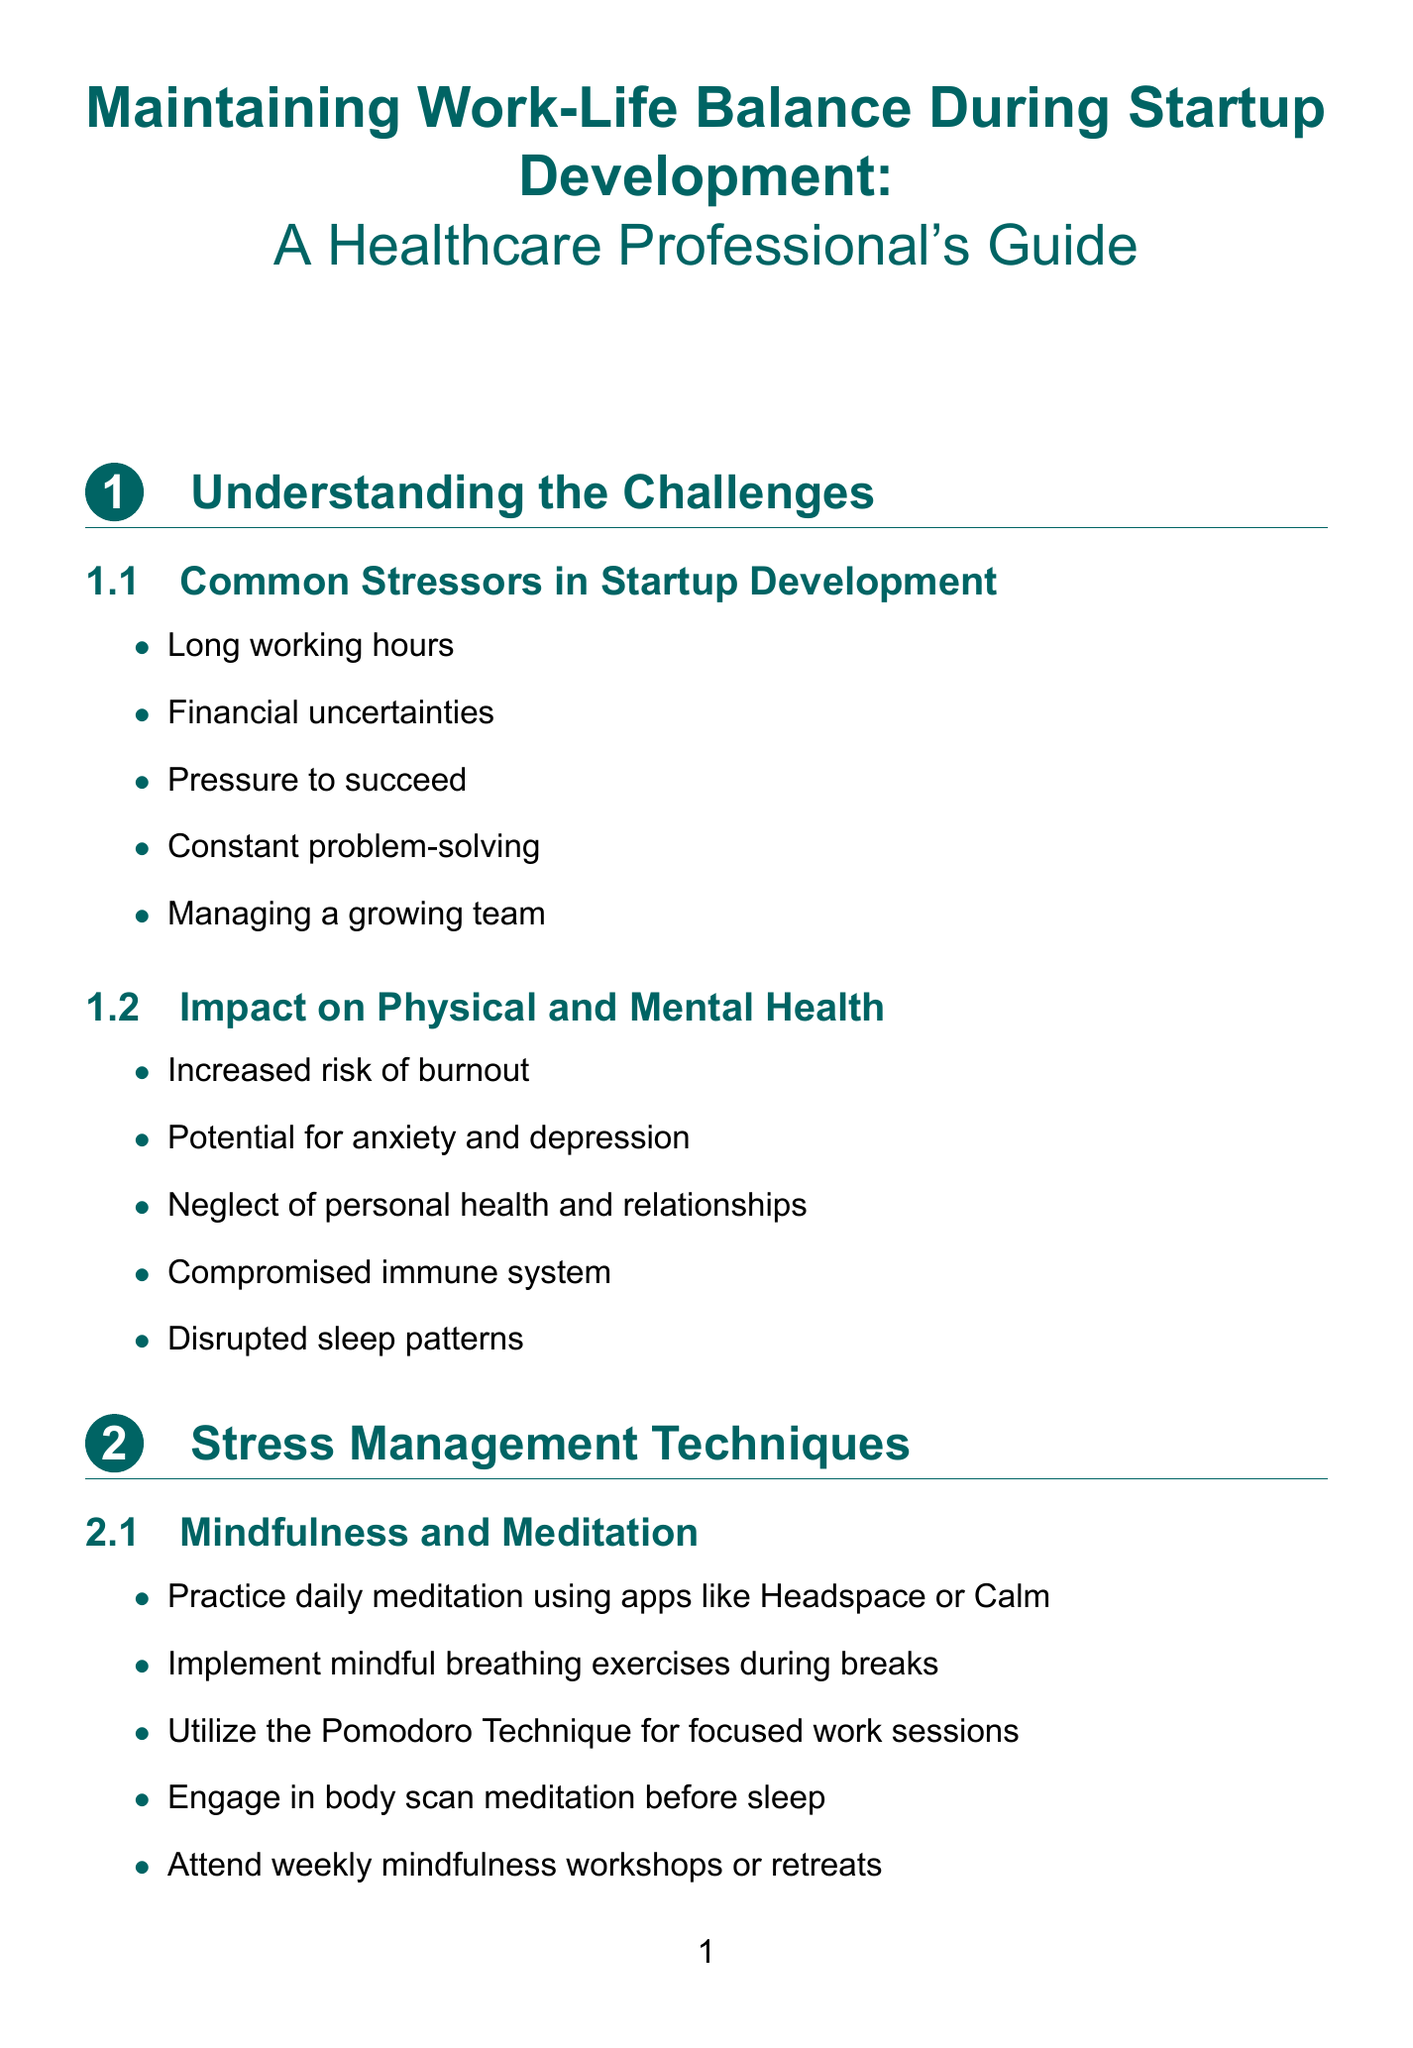What are common stressors in startup development? Common stressors include long working hours, financial uncertainties, pressure to succeed, constant problem-solving, and managing a growing team.
Answer: Long working hours, financial uncertainties, pressure to succeed, constant problem-solving, managing a growing team How can mindfulness be practiced during breaks? The document mentions implementing mindful breathing exercises during breaks as a stress management technique.
Answer: Mindful breathing exercises What is one benefit of physical exercise mentioned? The content outlines that physical exercise can help in scheduling regular gym sessions at facilities like Equinox or Planet Fitness.
Answer: Regular gym sessions What should be included in a relaxing bedtime routine? The document suggests creating a relaxing bedtime routine as part of sleep hygiene practices.
Answer: Relaxing bedtime routine What is a recommended productivity tool? The document lists productivity tools like Asana or Trello as part of time management techniques.
Answer: Asana or Trello How often should team-building activities occur? The document advises organizing monthly team-building activities within the supportive work environment section.
Answer: Monthly What is one way to implement flexible work arrangements? Offering remote work options is one way to incorporate flexible work arrangements.
Answer: Remote work options What is a key strategy for balancing entrepreneurial roles? Setting boundaries between clinical work and startup responsibilities is emphasized as a key strategy.
Answer: Setting boundaries Which app is suggested for practicing mental health support? The document recommends using mental health apps like Talkspace or BetterHelp.
Answer: Talkspace or BetterHelp 